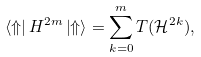Convert formula to latex. <formula><loc_0><loc_0><loc_500><loc_500>\left \langle \Uparrow \right | H ^ { 2 m } \left | \Uparrow \right \rangle = \sum _ { k = 0 } ^ { m } T ( \mathcal { H } ^ { 2 k } ) ,</formula> 